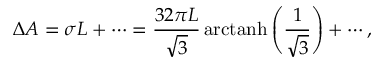Convert formula to latex. <formula><loc_0><loc_0><loc_500><loc_500>\Delta A = \sigma L + \cdots = \frac { 3 2 \pi L } { \sqrt { 3 } } \, a r c t a n h \left ( \frac { 1 } { \sqrt { 3 } } \right ) + \cdots ,</formula> 